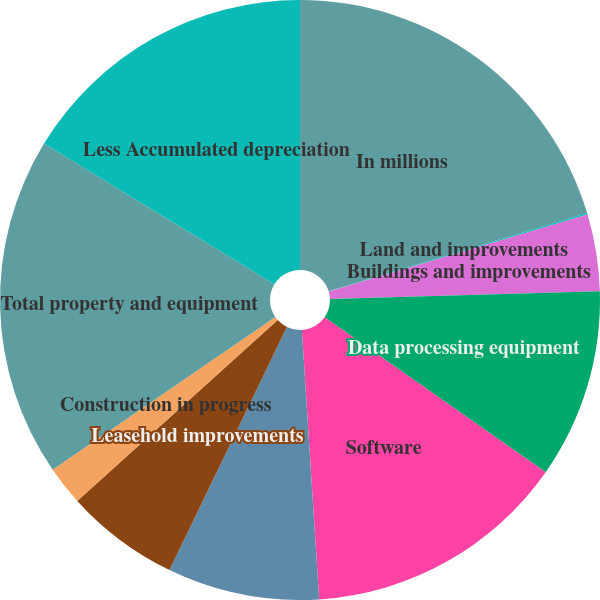Convert chart. <chart><loc_0><loc_0><loc_500><loc_500><pie_chart><fcel>In millions<fcel>Land and improvements<fcel>Buildings and improvements<fcel>Data processing equipment<fcel>Software<fcel>Furniture fixtures and<fcel>Leasehold improvements<fcel>Construction in progress<fcel>Total property and equipment<fcel>Less Accumulated depreciation<nl><fcel>20.32%<fcel>0.08%<fcel>4.13%<fcel>10.2%<fcel>14.25%<fcel>8.18%<fcel>6.15%<fcel>2.11%<fcel>18.3%<fcel>16.27%<nl></chart> 